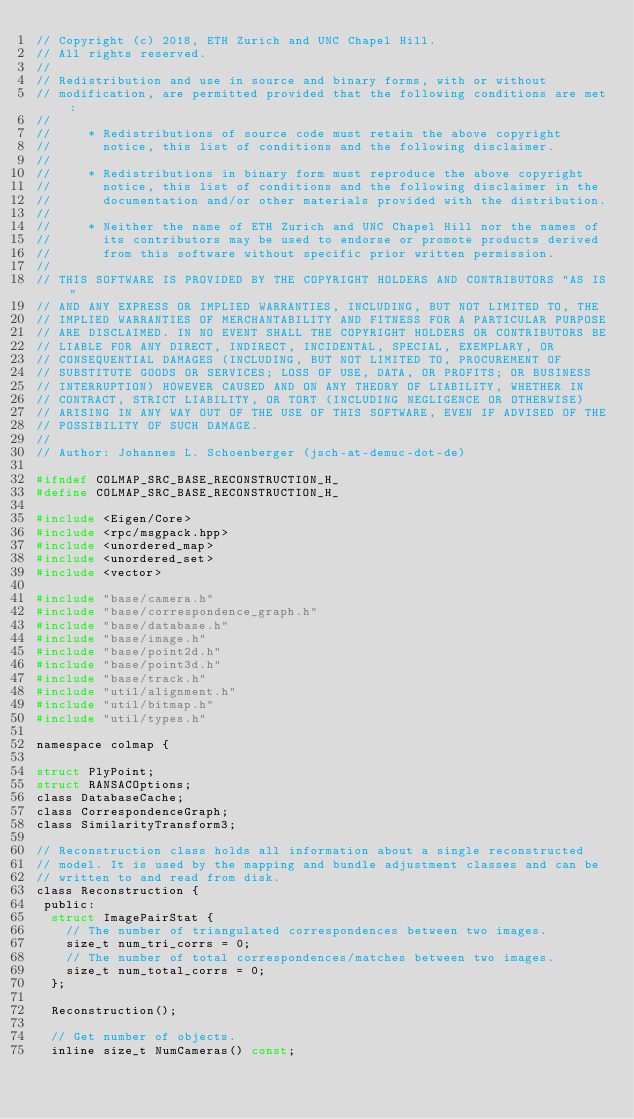<code> <loc_0><loc_0><loc_500><loc_500><_C_>// Copyright (c) 2018, ETH Zurich and UNC Chapel Hill.
// All rights reserved.
//
// Redistribution and use in source and binary forms, with or without
// modification, are permitted provided that the following conditions are met:
//
//     * Redistributions of source code must retain the above copyright
//       notice, this list of conditions and the following disclaimer.
//
//     * Redistributions in binary form must reproduce the above copyright
//       notice, this list of conditions and the following disclaimer in the
//       documentation and/or other materials provided with the distribution.
//
//     * Neither the name of ETH Zurich and UNC Chapel Hill nor the names of
//       its contributors may be used to endorse or promote products derived
//       from this software without specific prior written permission.
//
// THIS SOFTWARE IS PROVIDED BY THE COPYRIGHT HOLDERS AND CONTRIBUTORS "AS IS"
// AND ANY EXPRESS OR IMPLIED WARRANTIES, INCLUDING, BUT NOT LIMITED TO, THE
// IMPLIED WARRANTIES OF MERCHANTABILITY AND FITNESS FOR A PARTICULAR PURPOSE
// ARE DISCLAIMED. IN NO EVENT SHALL THE COPYRIGHT HOLDERS OR CONTRIBUTORS BE
// LIABLE FOR ANY DIRECT, INDIRECT, INCIDENTAL, SPECIAL, EXEMPLARY, OR
// CONSEQUENTIAL DAMAGES (INCLUDING, BUT NOT LIMITED TO, PROCUREMENT OF
// SUBSTITUTE GOODS OR SERVICES; LOSS OF USE, DATA, OR PROFITS; OR BUSINESS
// INTERRUPTION) HOWEVER CAUSED AND ON ANY THEORY OF LIABILITY, WHETHER IN
// CONTRACT, STRICT LIABILITY, OR TORT (INCLUDING NEGLIGENCE OR OTHERWISE)
// ARISING IN ANY WAY OUT OF THE USE OF THIS SOFTWARE, EVEN IF ADVISED OF THE
// POSSIBILITY OF SUCH DAMAGE.
//
// Author: Johannes L. Schoenberger (jsch-at-demuc-dot-de)

#ifndef COLMAP_SRC_BASE_RECONSTRUCTION_H_
#define COLMAP_SRC_BASE_RECONSTRUCTION_H_

#include <Eigen/Core>
#include <rpc/msgpack.hpp>
#include <unordered_map>
#include <unordered_set>
#include <vector>

#include "base/camera.h"
#include "base/correspondence_graph.h"
#include "base/database.h"
#include "base/image.h"
#include "base/point2d.h"
#include "base/point3d.h"
#include "base/track.h"
#include "util/alignment.h"
#include "util/bitmap.h"
#include "util/types.h"

namespace colmap {

struct PlyPoint;
struct RANSACOptions;
class DatabaseCache;
class CorrespondenceGraph;
class SimilarityTransform3;

// Reconstruction class holds all information about a single reconstructed
// model. It is used by the mapping and bundle adjustment classes and can be
// written to and read from disk.
class Reconstruction {
 public:
  struct ImagePairStat {
    // The number of triangulated correspondences between two images.
    size_t num_tri_corrs = 0;
    // The number of total correspondences/matches between two images.
    size_t num_total_corrs = 0;
  };

  Reconstruction();

  // Get number of objects.
  inline size_t NumCameras() const;</code> 